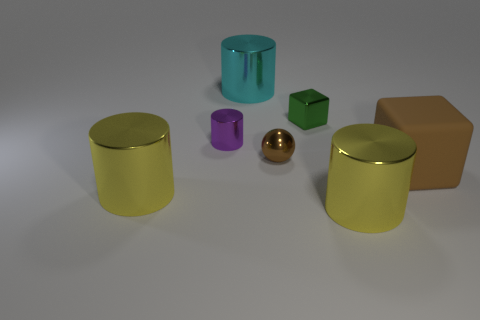Subtract all blue cylinders. Subtract all brown balls. How many cylinders are left? 4 Add 1 big shiny objects. How many objects exist? 8 Subtract all cubes. How many objects are left? 5 Add 2 tiny metal spheres. How many tiny metal spheres exist? 3 Subtract 0 blue cylinders. How many objects are left? 7 Subtract all red metallic cylinders. Subtract all blocks. How many objects are left? 5 Add 6 tiny brown things. How many tiny brown things are left? 7 